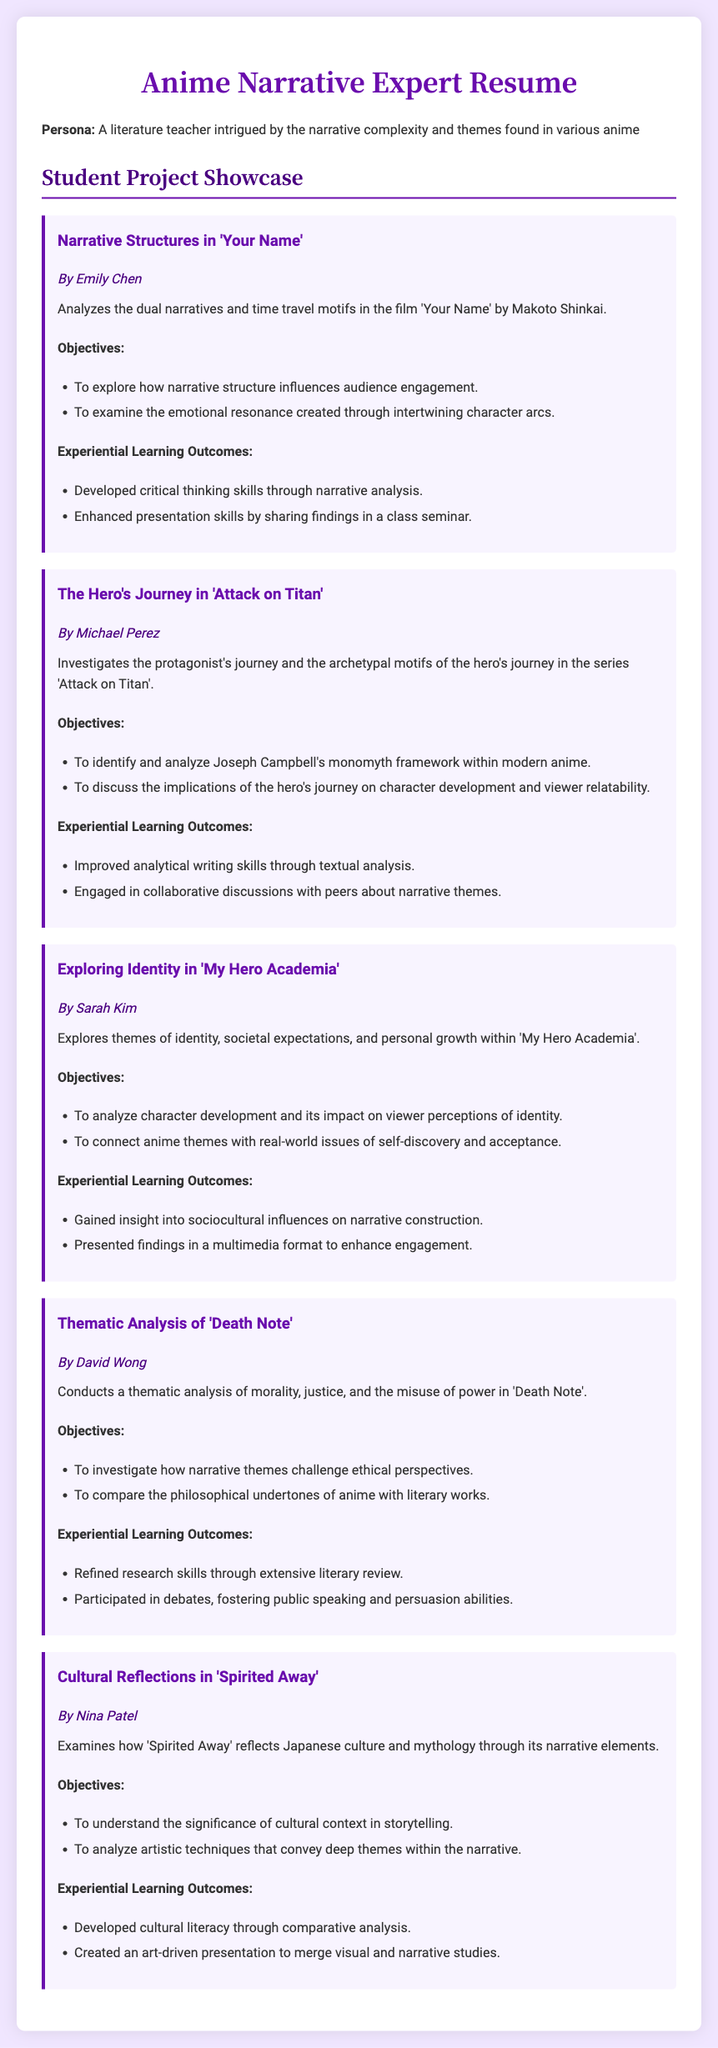What is the title of the first project? The title of the first project is presented in the document under the project section as “Narrative Structures in 'Your Name'.”
Answer: Narrative Structures in 'Your Name' Who is the student behind the project on 'Attack on Titan'? The student associated with the 'Attack on Titan' project is mentioned directly in the description of the project section.
Answer: Michael Perez What is one of the objectives of the project on 'My Hero Academia'? The objectives for 'My Hero Academia' are listed in bullet points, with one of them specified clearly.
Answer: To analyze character development and its impact on viewer perceptions of identity What theme does the project on 'Death Note' primarily focus on? The thematic focus of the 'Death Note' project is mentioned in the project description, indicating its central theme.
Answer: Morality, justice, and the misuse of power What artistic technique did Nina Patel analyze in her project? The document states the purpose of the project, which includes analyzing specific artistic techniques within the narrative.
Answer: Artistic techniques that convey deep themes within the narrative How many projects are listed in the showcase? The total number of projects is determined by counting each project description in the document.
Answer: Five What did Sarah Kim gain insight into through her project? The experiential learning outcomes mention the insights gained by Sarah Kim during her project.
Answer: Sociocultural influences on narrative construction Which anime does David Wong’s project analyze? The document clearly states the title of the anime that David Wong’s project focuses on.
Answer: Death Note What format did Nina Patel use to present her findings? The document indicates that Nina Patel created a specific presentation type to share her work.
Answer: Art-driven presentation 